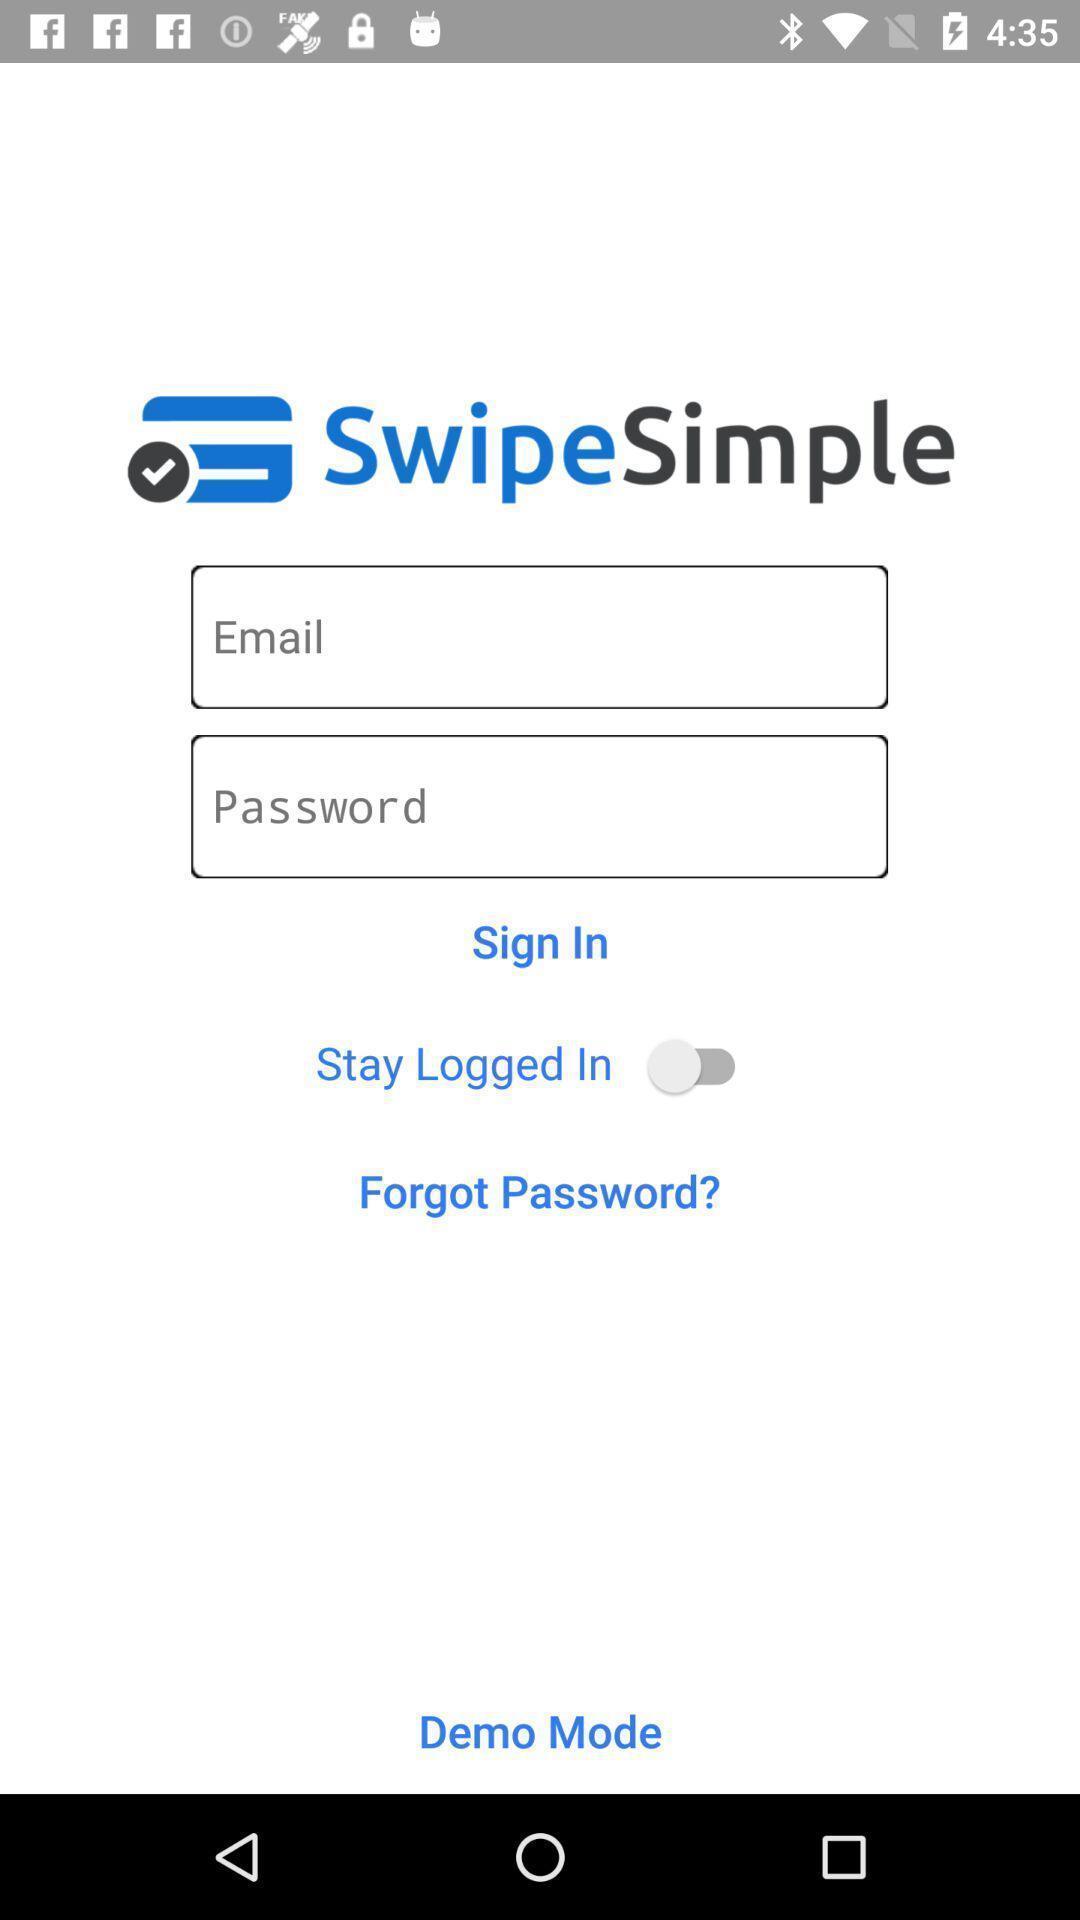Summarize the information in this screenshot. Sign in page. 